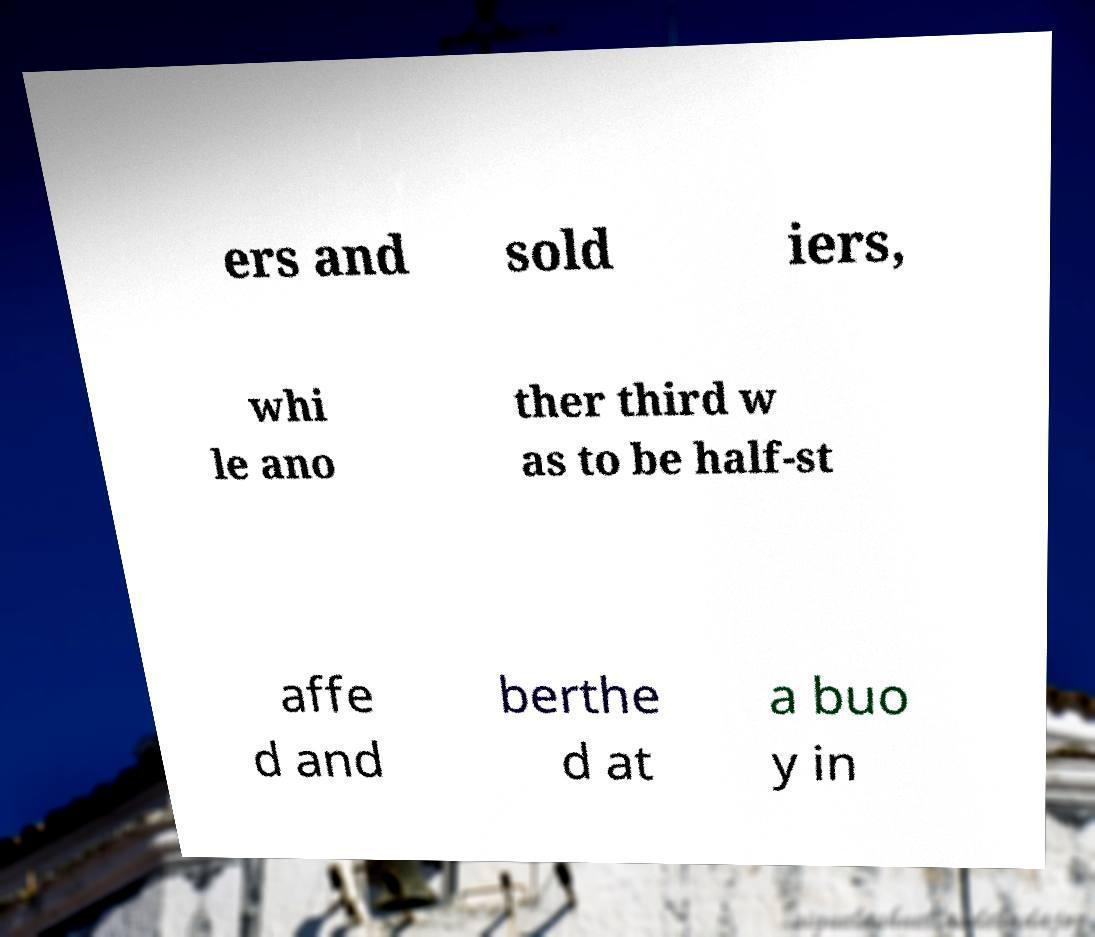I need the written content from this picture converted into text. Can you do that? ers and sold iers, whi le ano ther third w as to be half-st affe d and berthe d at a buo y in 